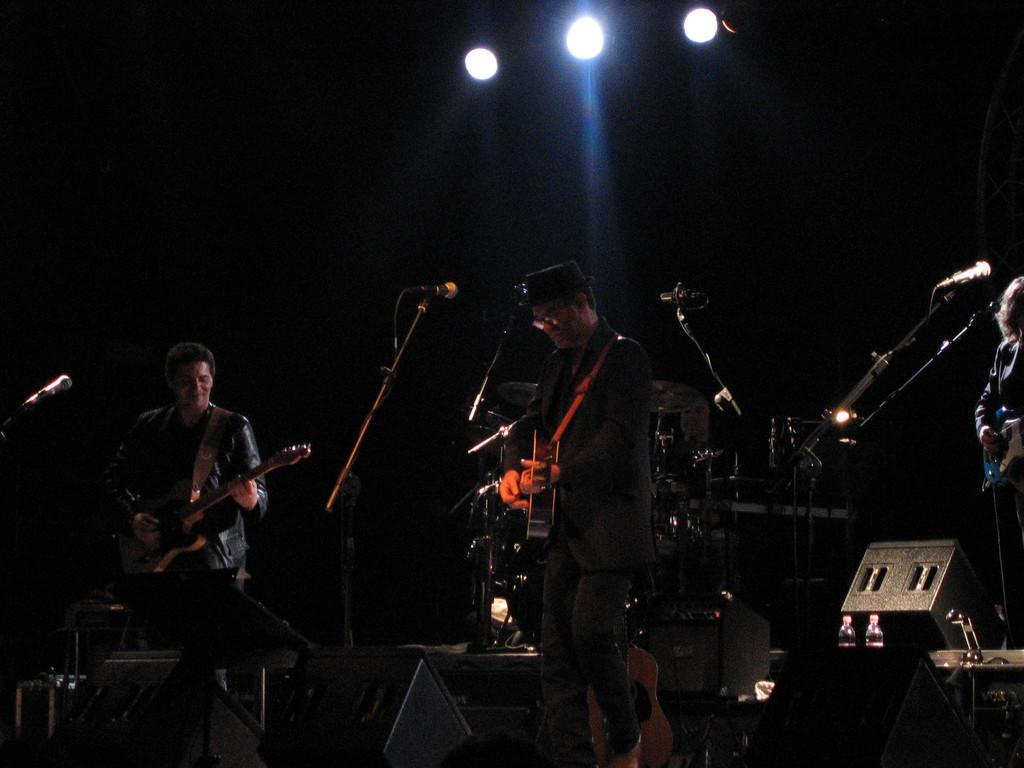How many people are in the image? There are two persons in the image. What are the persons doing in the image? The persons are standing and playing a guitar. What other objects related to music can be seen in the image? There are musical instruments and a microphone with a mic holder in the image. What can be seen in the image that might be used for lighting purposes? There are focusing lights visible in the image. What type of celery is being used as a prop in the image? There is no celery present in the image; it features two persons playing a guitar and related musical equipment. 